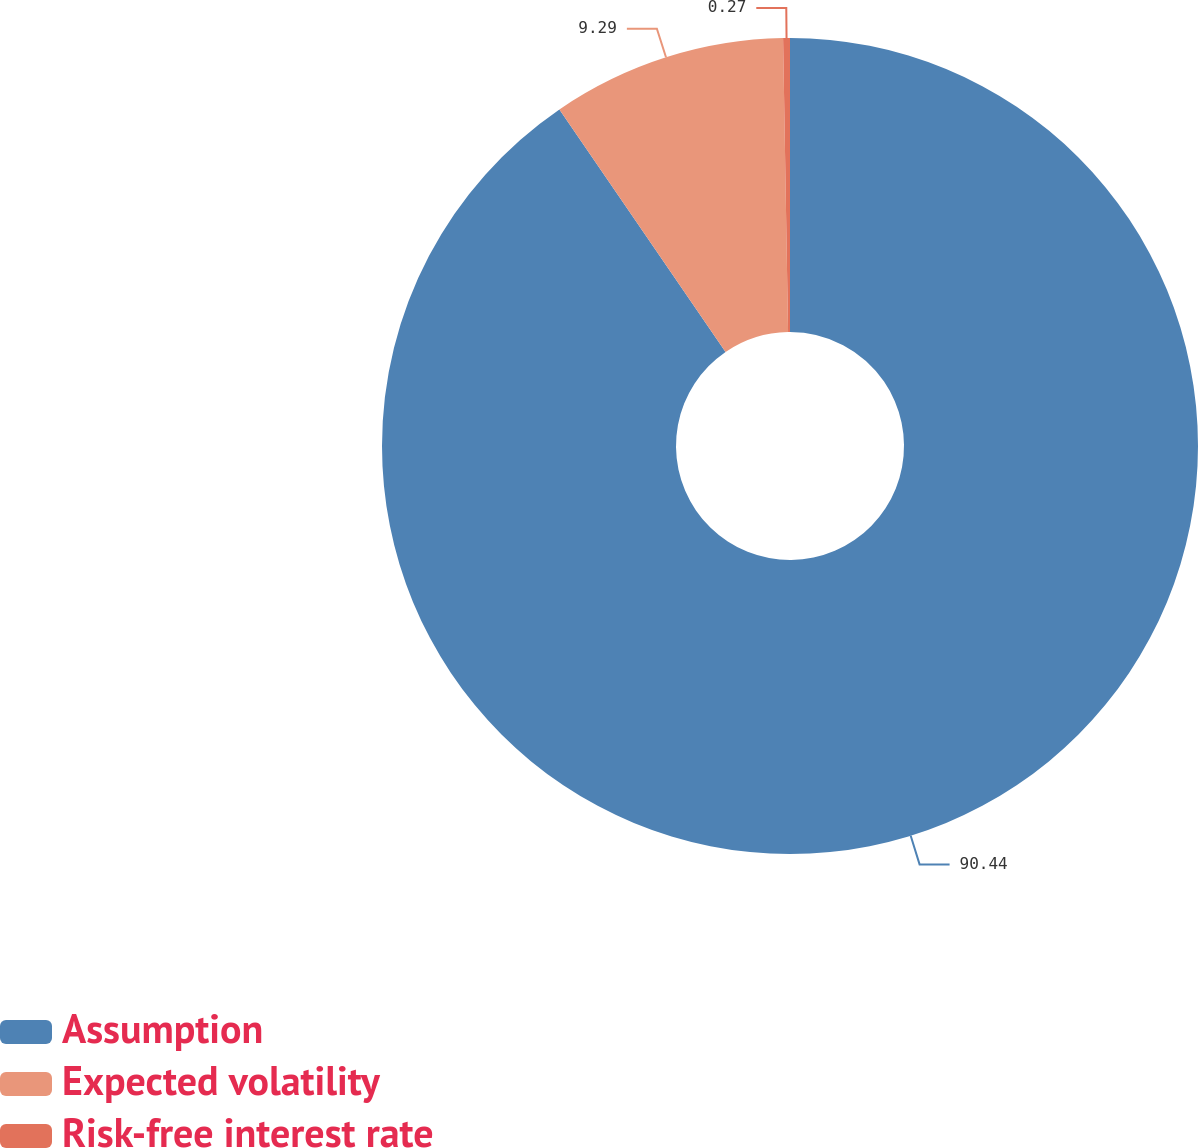Convert chart to OTSL. <chart><loc_0><loc_0><loc_500><loc_500><pie_chart><fcel>Assumption<fcel>Expected volatility<fcel>Risk-free interest rate<nl><fcel>90.44%<fcel>9.29%<fcel>0.27%<nl></chart> 